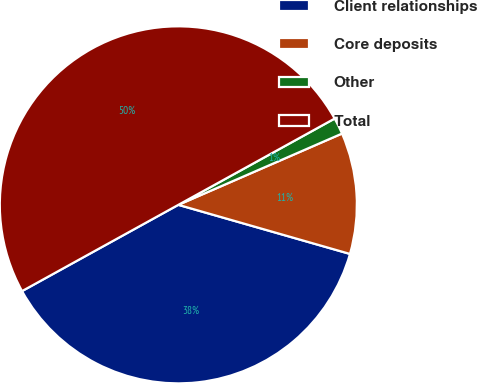Convert chart to OTSL. <chart><loc_0><loc_0><loc_500><loc_500><pie_chart><fcel>Client relationships<fcel>Core deposits<fcel>Other<fcel>Total<nl><fcel>37.54%<fcel>10.97%<fcel>1.49%<fcel>50.0%<nl></chart> 